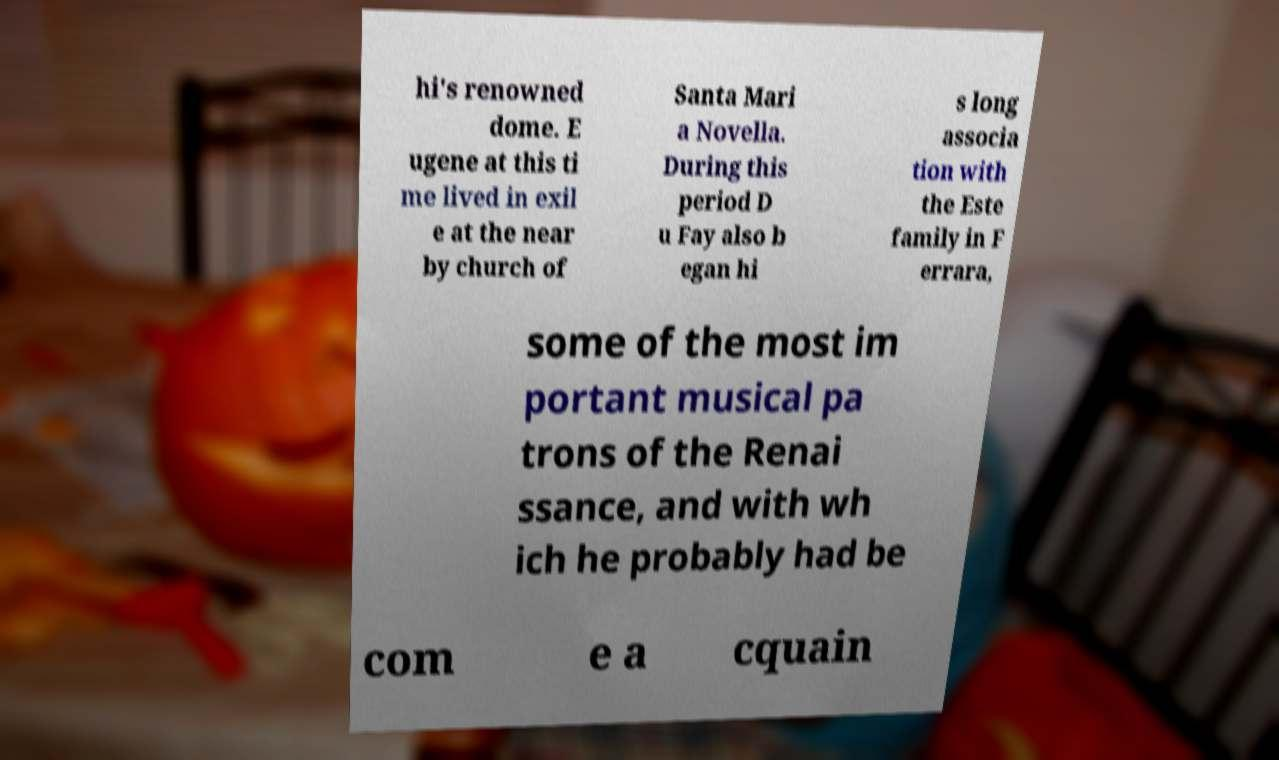Please identify and transcribe the text found in this image. hi's renowned dome. E ugene at this ti me lived in exil e at the near by church of Santa Mari a Novella. During this period D u Fay also b egan hi s long associa tion with the Este family in F errara, some of the most im portant musical pa trons of the Renai ssance, and with wh ich he probably had be com e a cquain 